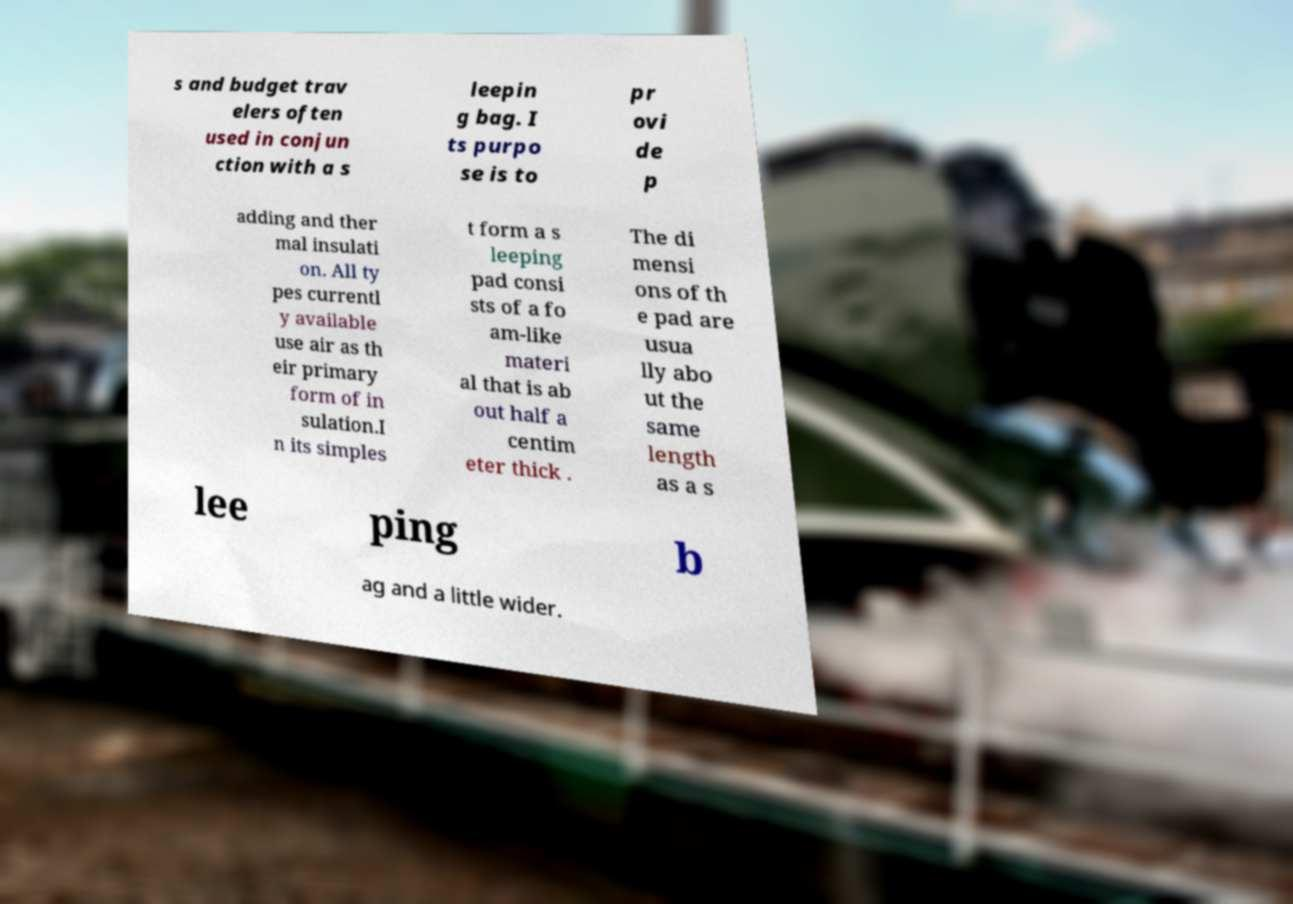Please identify and transcribe the text found in this image. s and budget trav elers often used in conjun ction with a s leepin g bag. I ts purpo se is to pr ovi de p adding and ther mal insulati on. All ty pes currentl y available use air as th eir primary form of in sulation.I n its simples t form a s leeping pad consi sts of a fo am-like materi al that is ab out half a centim eter thick . The di mensi ons of th e pad are usua lly abo ut the same length as a s lee ping b ag and a little wider. 